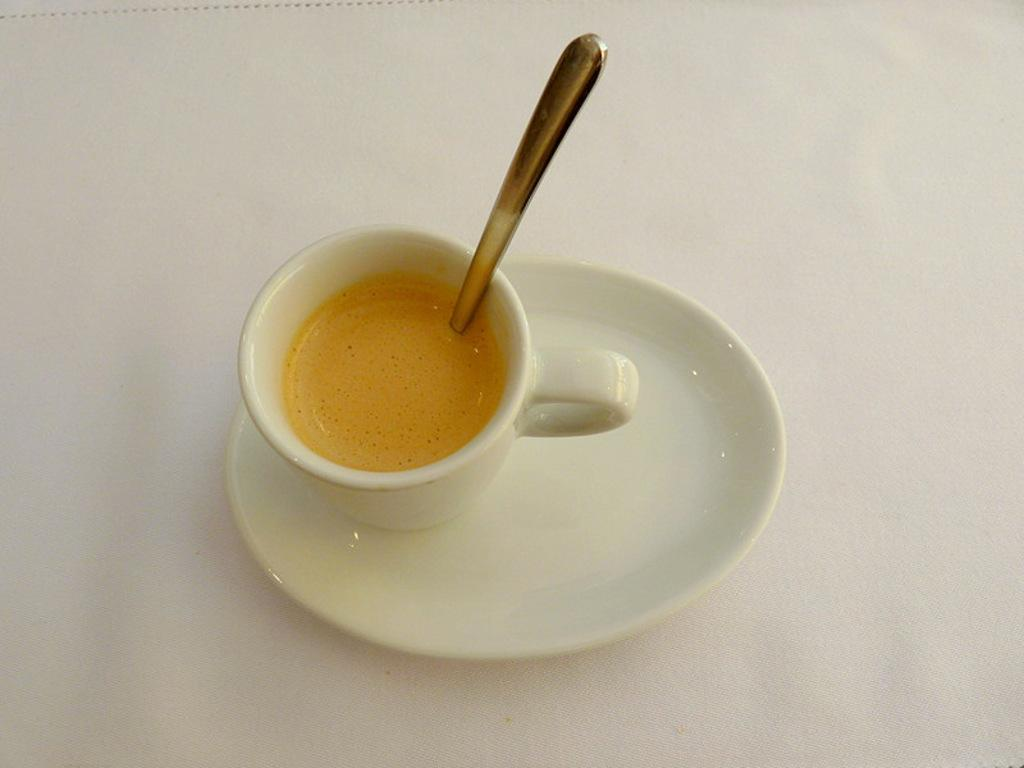What is present in the image alongside the cup? There is a saucer in the image. What is inside the cup? There is a drink in the cup. What utensil is placed in the cup? There is a spoon in the cup. What color is the background of the image? The background of the image is white. What type of advertisement is displayed on the cup in the image? There is no advertisement displayed on the cup in the image. How many grams of mass can be measured using the spoon in the image? The spoon's mass is not mentioned in the image, and it is not used for measuring mass. 